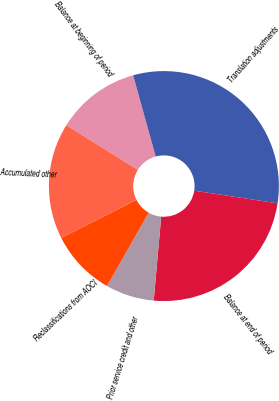Convert chart to OTSL. <chart><loc_0><loc_0><loc_500><loc_500><pie_chart><fcel>Balance at beginning of period<fcel>Translation adjustments<fcel>Balance at end of period<fcel>Prior service credit and other<fcel>Reclassifications from AOCI<fcel>Accumulated other<nl><fcel>11.81%<fcel>31.7%<fcel>24.01%<fcel>6.83%<fcel>9.32%<fcel>16.32%<nl></chart> 